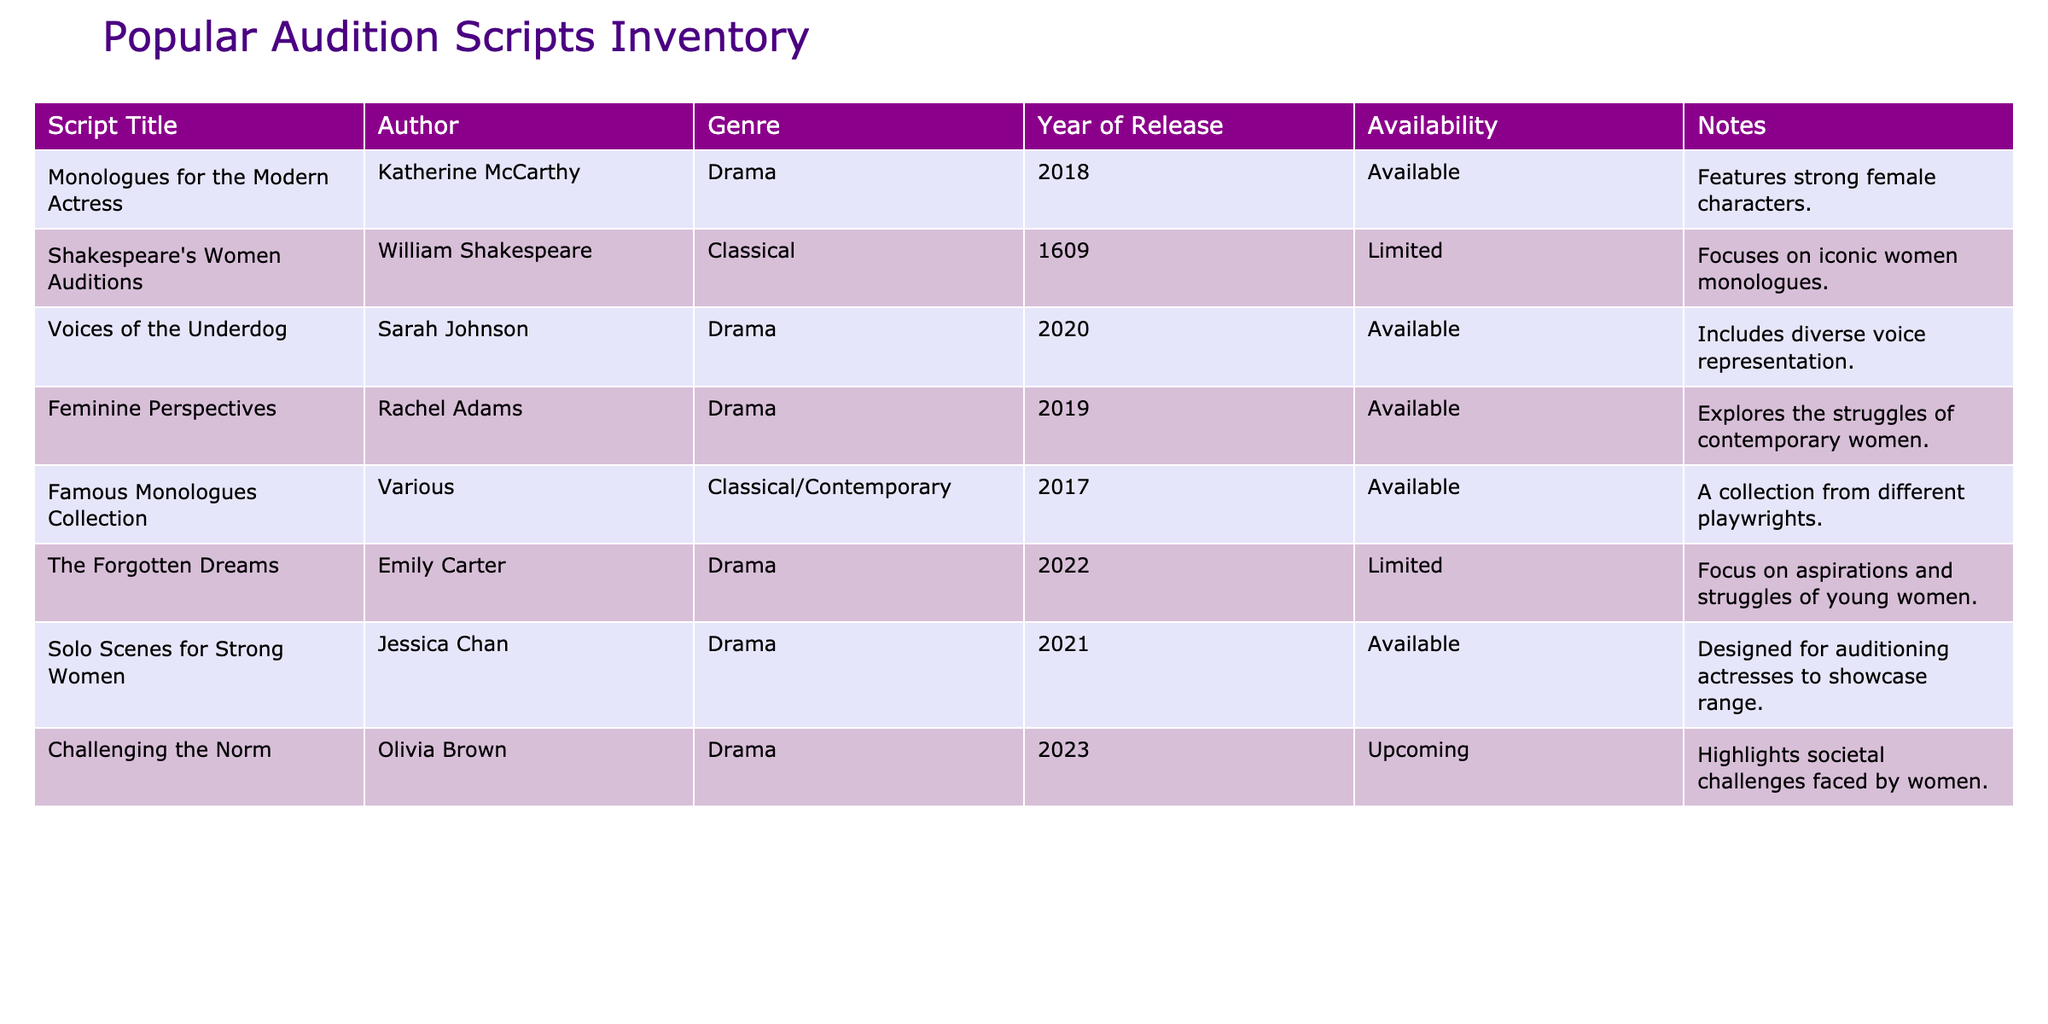What are the titles of the scripts written by female authors? From the table, I will look for entries under the 'Author' column that are associated with female names. The relevant entries are "Monologues for the Modern Actress" by Katherine McCarthy, "Voices of the Underdog" by Sarah Johnson, "Feminine Perspectives" by Rachel Adams, "The Forgotten Dreams" by Emily Carter, and "Solo Scenes for Strong Women" by Jessica Chan.
Answer: "Monologues for the Modern Actress", "Voices of the Underdog", "Feminine Perspectives", "The Forgotten Dreams", "Solo Scenes for Strong Women" Is there a script that focuses on societal challenges faced by women? I can quickly scan the 'Notes' column for mentions of societal challenges. The script "Challenging the Norm" highlights societal challenges faced by women, confirming that this script is indeed focused on that theme.
Answer: Yes How many scripts are classified under the Drama genre? To find the count, I will go through each row and tally the entries that belong to the 'Drama' genre. The scripts "Monologues for the Modern Actress", "Voices of the Underdog", "Feminine Perspectives", "Solo Scenes for Strong Women", "The Forgotten Dreams", and "Challenging the Norm" fall under Drama, making a total of 6 scripts.
Answer: 6 Which script was released most recently and what is its availability? I will look through the 'Year of Release' column and identify the largest number, which denotes the most recent release. The script "Challenging the Norm" was released in 2023 and its availability status is "Upcoming".
Answer: "Challenging the Norm", Upcoming Are there any scripts available that were published after 2018? I will filter through the 'Year of Release' column for entries greater than 2018. The scripts "Voices of the Underdog" (2020), "Feminine Perspectives" (2019), "Solo Scenes for Strong Women" (2021), and "Challenging the Norm" (2023) are all published after 2018 and are available as per the 'Availability' column.
Answer: Yes, 4 scripts 